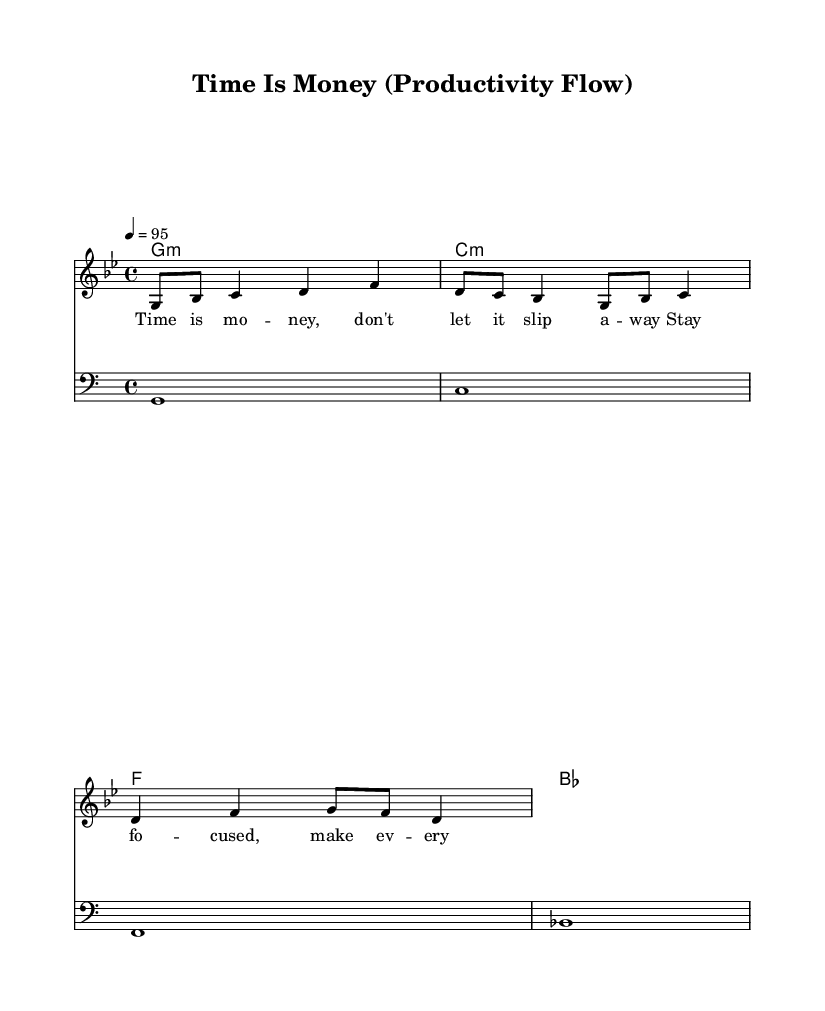What is the key signature of this music? The key signature is G minor, indicated by two flats in the key signature area.
Answer: G minor What is the time signature of this music? The time signature appears at the beginning of the score and is shown as 4/4, meaning there are four beats in each measure.
Answer: 4/4 What is the tempo marking of this music? The tempo marking at the beginning states “4 = 95,” indicating that there are 95 beats per minute at quarter note value.
Answer: 95 How many measures are in the melody? By counting the groupings of notes separated by vertical lines, there are four measures in the melody portion of the sheet music.
Answer: 4 What type of musical elements are emphasized in the lyrics? The lyrics focus on productivity and time management, highlighting phrases such as "Time is money" and urging focus and effective use of time.
Answer: Productivity What is the bass clef used for in this music? The bass clef is used to indicate the lower pitch range, which in this piece complements the melody and chords by providing harmonic support.
Answer: Harmony Which chord is played in the first measure of harmonies? The first measure has a G minor chord, indicated by "g1:m" in the chord names.
Answer: G minor 